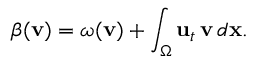<formula> <loc_0><loc_0><loc_500><loc_500>\beta ( { \mathbf v } ) = \omega ( { \mathbf v } ) + \int _ { \Omega } { \mathbf u } _ { t } \, { \mathbf v } \, d { \mathbf x } .</formula> 